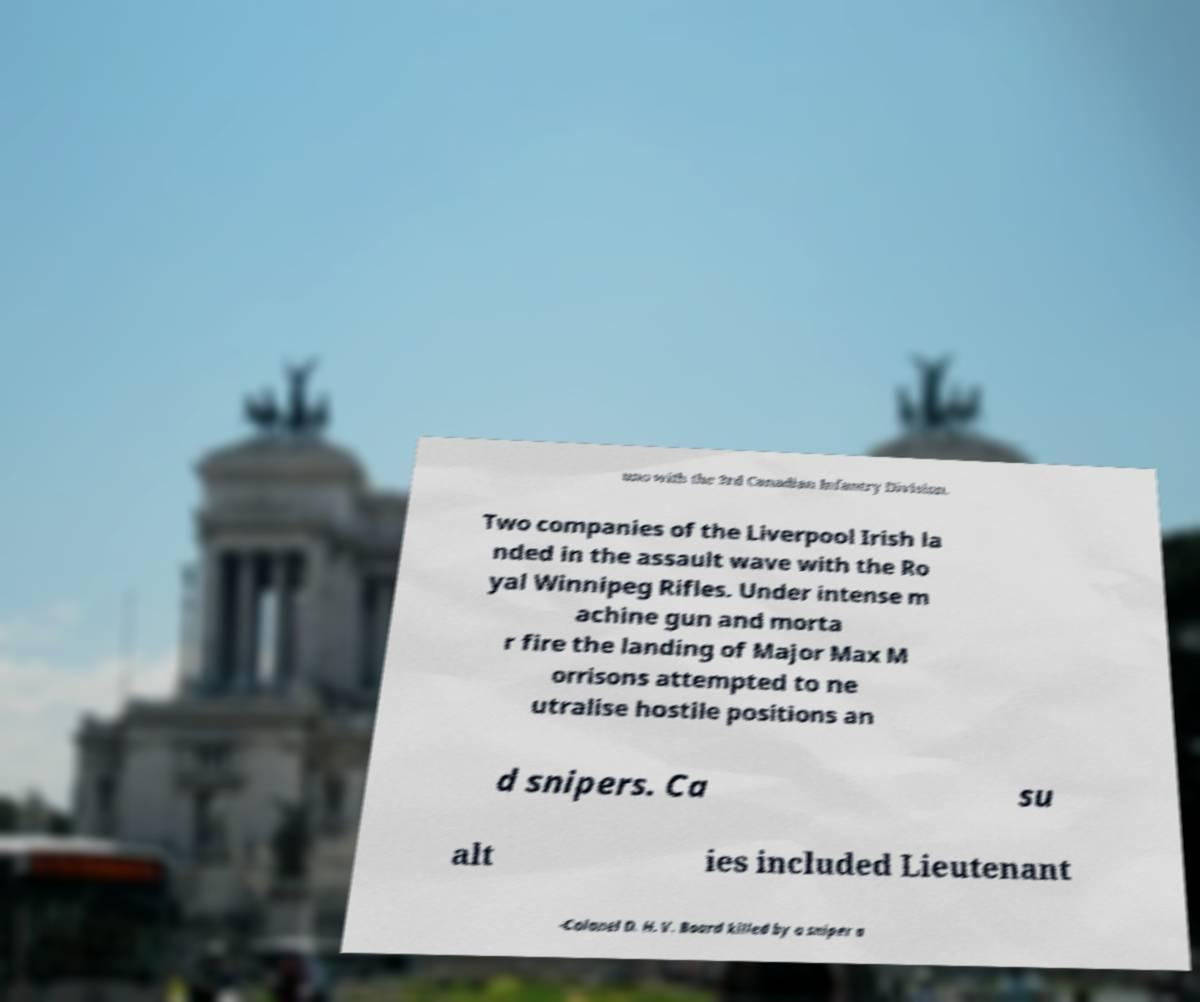Can you read and provide the text displayed in the image?This photo seems to have some interesting text. Can you extract and type it out for me? uno with the 3rd Canadian Infantry Division. Two companies of the Liverpool Irish la nded in the assault wave with the Ro yal Winnipeg Rifles. Under intense m achine gun and morta r fire the landing of Major Max M orrisons attempted to ne utralise hostile positions an d snipers. Ca su alt ies included Lieutenant -Colonel D. H. V. Board killed by a sniper a 